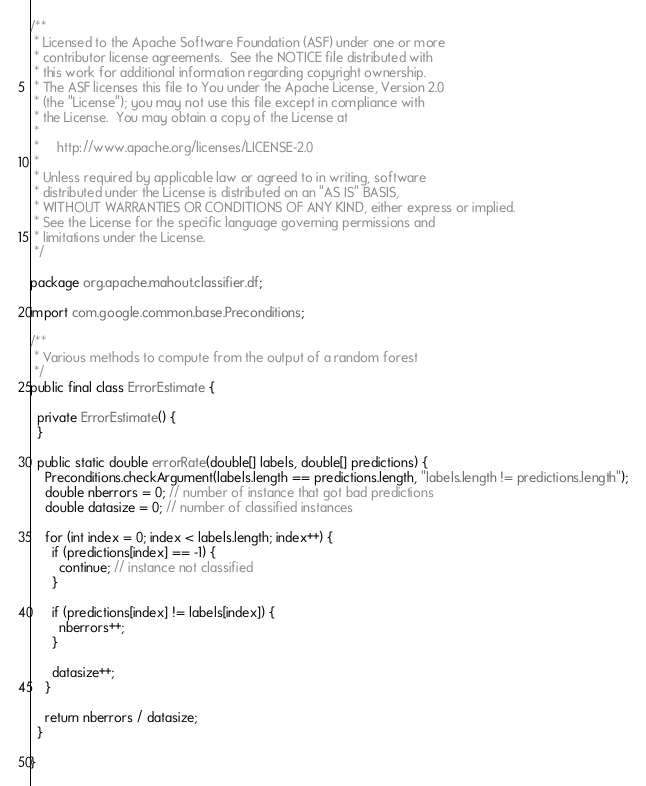<code> <loc_0><loc_0><loc_500><loc_500><_Java_>/**
 * Licensed to the Apache Software Foundation (ASF) under one or more
 * contributor license agreements.  See the NOTICE file distributed with
 * this work for additional information regarding copyright ownership.
 * The ASF licenses this file to You under the Apache License, Version 2.0
 * (the "License"); you may not use this file except in compliance with
 * the License.  You may obtain a copy of the License at
 *
 *     http://www.apache.org/licenses/LICENSE-2.0
 *
 * Unless required by applicable law or agreed to in writing, software
 * distributed under the License is distributed on an "AS IS" BASIS,
 * WITHOUT WARRANTIES OR CONDITIONS OF ANY KIND, either express or implied.
 * See the License for the specific language governing permissions and
 * limitations under the License.
 */

package org.apache.mahout.classifier.df;

import com.google.common.base.Preconditions;

/**
 * Various methods to compute from the output of a random forest
 */
public final class ErrorEstimate {

  private ErrorEstimate() {
  }
  
  public static double errorRate(double[] labels, double[] predictions) {
    Preconditions.checkArgument(labels.length == predictions.length, "labels.length != predictions.length");
    double nberrors = 0; // number of instance that got bad predictions
    double datasize = 0; // number of classified instances

    for (int index = 0; index < labels.length; index++) {
      if (predictions[index] == -1) {
        continue; // instance not classified
      }

      if (predictions[index] != labels[index]) {
        nberrors++;
      }

      datasize++;
    }

    return nberrors / datasize;
  }

}
</code> 